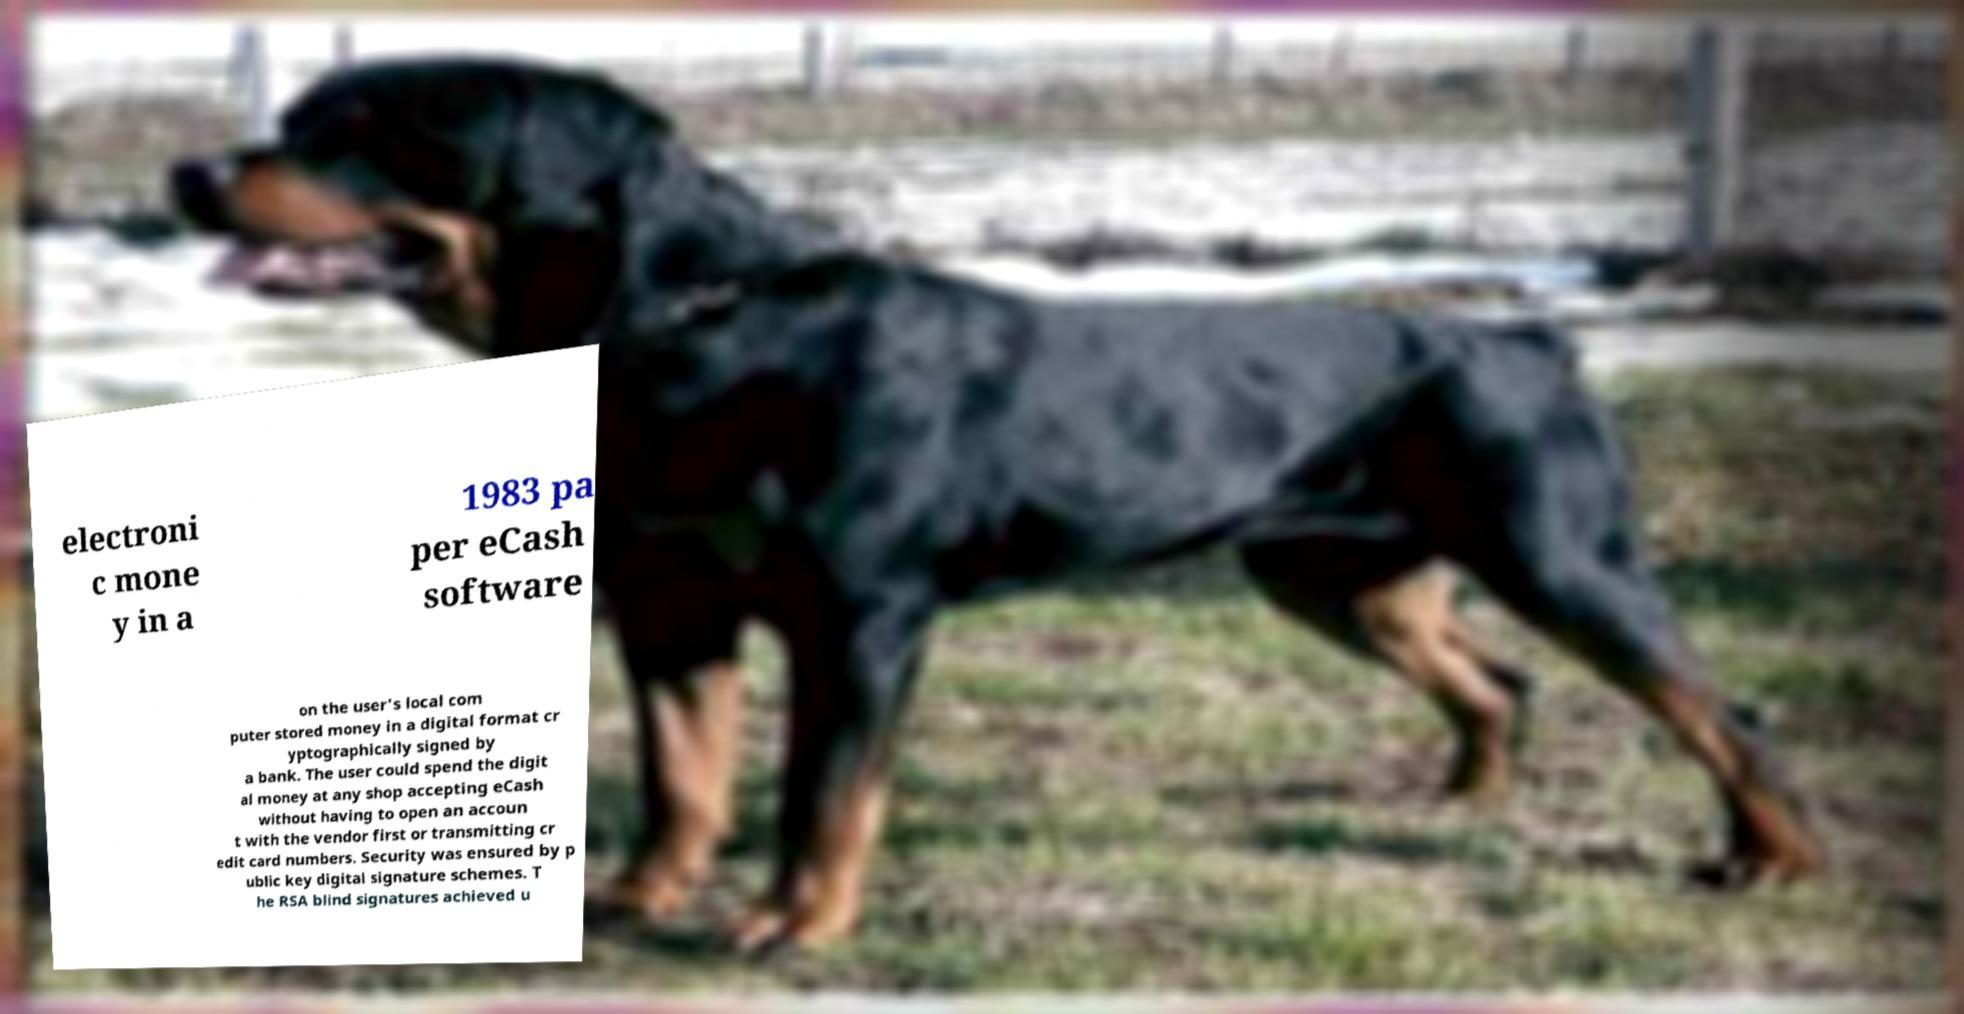Can you accurately transcribe the text from the provided image for me? electroni c mone y in a 1983 pa per eCash software on the user's local com puter stored money in a digital format cr yptographically signed by a bank. The user could spend the digit al money at any shop accepting eCash without having to open an accoun t with the vendor first or transmitting cr edit card numbers. Security was ensured by p ublic key digital signature schemes. T he RSA blind signatures achieved u 